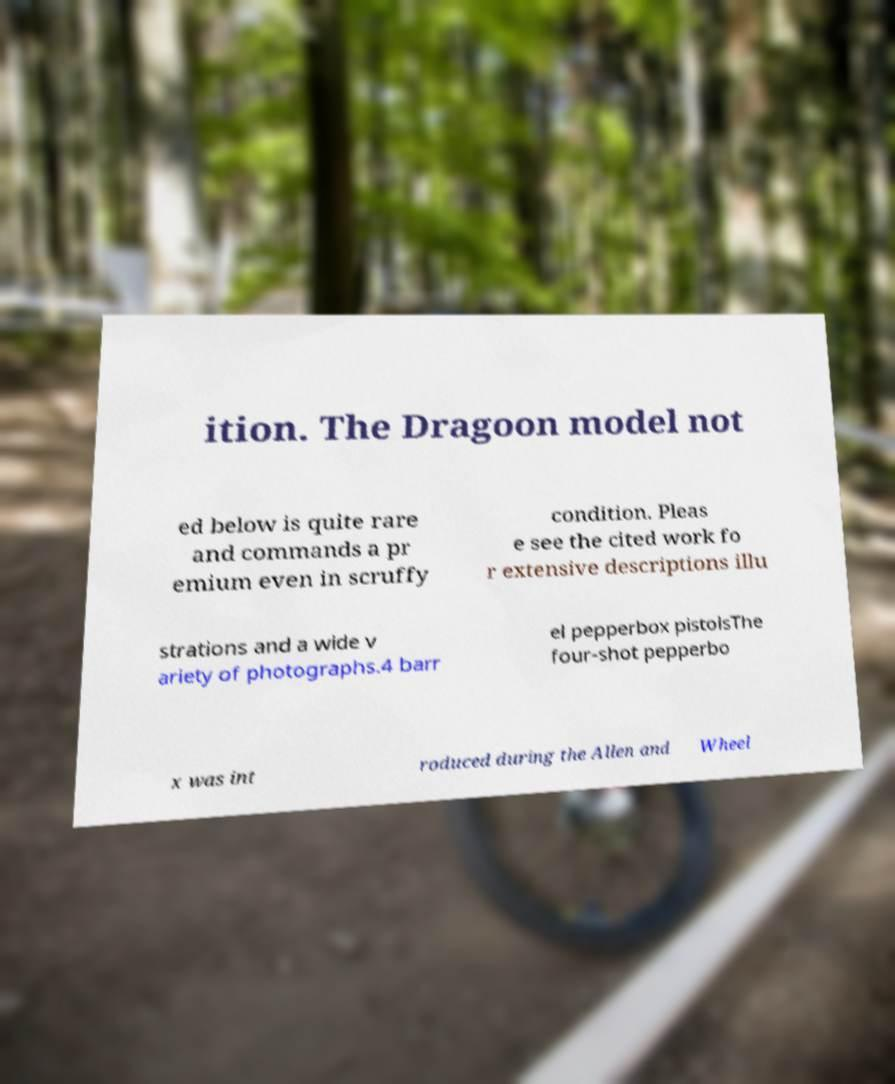Could you assist in decoding the text presented in this image and type it out clearly? ition. The Dragoon model not ed below is quite rare and commands a pr emium even in scruffy condition. Pleas e see the cited work fo r extensive descriptions illu strations and a wide v ariety of photographs.4 barr el pepperbox pistolsThe four-shot pepperbo x was int roduced during the Allen and Wheel 